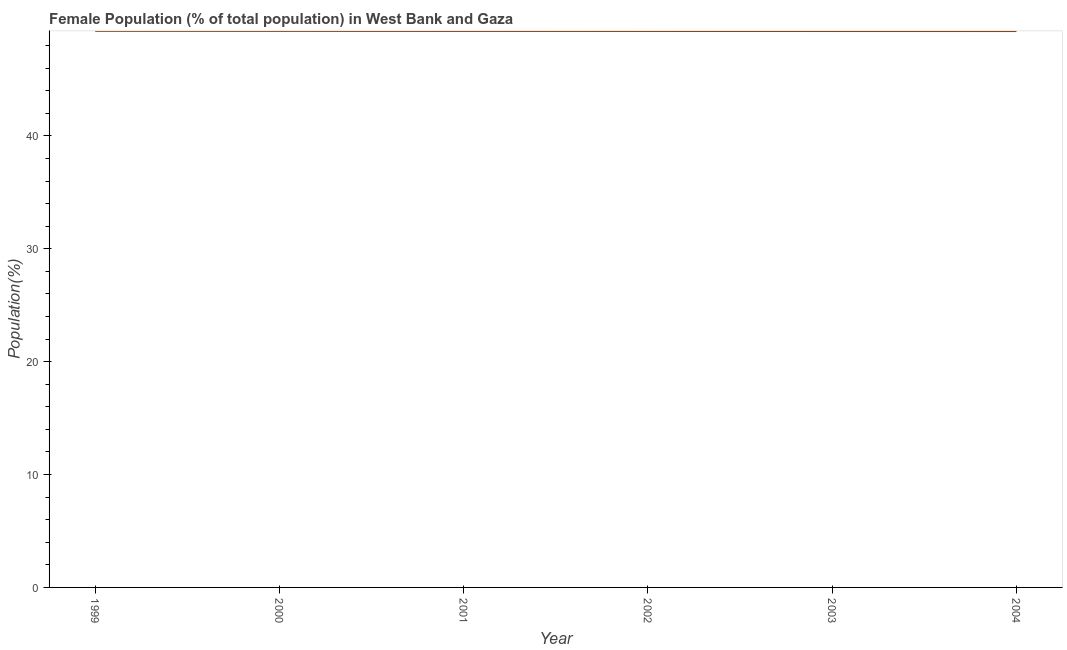What is the female population in 2001?
Offer a very short reply. 49.3. Across all years, what is the maximum female population?
Make the answer very short. 49.31. Across all years, what is the minimum female population?
Your response must be concise. 49.29. What is the sum of the female population?
Offer a terse response. 295.79. What is the difference between the female population in 2002 and 2004?
Your answer should be very brief. 0.01. What is the average female population per year?
Make the answer very short. 49.3. What is the median female population?
Ensure brevity in your answer.  49.3. Do a majority of the years between 1999 and 2004 (inclusive) have female population greater than 10 %?
Ensure brevity in your answer.  Yes. What is the ratio of the female population in 1999 to that in 2000?
Provide a short and direct response. 1. Is the difference between the female population in 1999 and 2004 greater than the difference between any two years?
Offer a very short reply. Yes. What is the difference between the highest and the second highest female population?
Offer a very short reply. 0. What is the difference between the highest and the lowest female population?
Provide a short and direct response. 0.02. In how many years, is the female population greater than the average female population taken over all years?
Your answer should be very brief. 3. Does the female population monotonically increase over the years?
Offer a very short reply. No. How many lines are there?
Make the answer very short. 1. How many years are there in the graph?
Keep it short and to the point. 6. Are the values on the major ticks of Y-axis written in scientific E-notation?
Give a very brief answer. No. Does the graph contain any zero values?
Ensure brevity in your answer.  No. Does the graph contain grids?
Give a very brief answer. No. What is the title of the graph?
Give a very brief answer. Female Population (% of total population) in West Bank and Gaza. What is the label or title of the X-axis?
Your response must be concise. Year. What is the label or title of the Y-axis?
Provide a succinct answer. Population(%). What is the Population(%) of 1999?
Give a very brief answer. 49.31. What is the Population(%) of 2000?
Ensure brevity in your answer.  49.3. What is the Population(%) in 2001?
Ensure brevity in your answer.  49.3. What is the Population(%) in 2002?
Offer a very short reply. 49.29. What is the Population(%) of 2003?
Provide a succinct answer. 49.29. What is the Population(%) of 2004?
Provide a succinct answer. 49.29. What is the difference between the Population(%) in 1999 and 2000?
Offer a terse response. 0. What is the difference between the Population(%) in 1999 and 2001?
Provide a short and direct response. 0.01. What is the difference between the Population(%) in 1999 and 2002?
Ensure brevity in your answer.  0.01. What is the difference between the Population(%) in 1999 and 2003?
Make the answer very short. 0.02. What is the difference between the Population(%) in 1999 and 2004?
Keep it short and to the point. 0.02. What is the difference between the Population(%) in 2000 and 2001?
Keep it short and to the point. 0. What is the difference between the Population(%) in 2000 and 2002?
Offer a very short reply. 0.01. What is the difference between the Population(%) in 2000 and 2003?
Provide a short and direct response. 0.01. What is the difference between the Population(%) in 2000 and 2004?
Give a very brief answer. 0.01. What is the difference between the Population(%) in 2001 and 2002?
Your answer should be very brief. 0. What is the difference between the Population(%) in 2001 and 2003?
Your answer should be very brief. 0.01. What is the difference between the Population(%) in 2001 and 2004?
Make the answer very short. 0.01. What is the difference between the Population(%) in 2002 and 2003?
Give a very brief answer. 0. What is the difference between the Population(%) in 2002 and 2004?
Give a very brief answer. 0.01. What is the difference between the Population(%) in 2003 and 2004?
Give a very brief answer. 0. What is the ratio of the Population(%) in 1999 to that in 2000?
Offer a terse response. 1. What is the ratio of the Population(%) in 1999 to that in 2002?
Your answer should be compact. 1. What is the ratio of the Population(%) in 1999 to that in 2003?
Give a very brief answer. 1. What is the ratio of the Population(%) in 2000 to that in 2001?
Offer a terse response. 1. What is the ratio of the Population(%) in 2000 to that in 2002?
Offer a very short reply. 1. What is the ratio of the Population(%) in 2000 to that in 2004?
Your response must be concise. 1. What is the ratio of the Population(%) in 2001 to that in 2003?
Keep it short and to the point. 1. What is the ratio of the Population(%) in 2001 to that in 2004?
Provide a short and direct response. 1. What is the ratio of the Population(%) in 2002 to that in 2004?
Your answer should be very brief. 1. What is the ratio of the Population(%) in 2003 to that in 2004?
Make the answer very short. 1. 